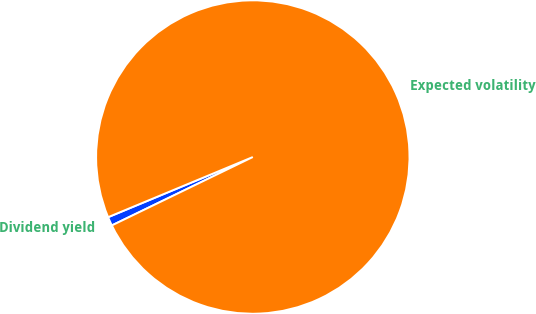Convert chart to OTSL. <chart><loc_0><loc_0><loc_500><loc_500><pie_chart><fcel>Dividend yield<fcel>Expected volatility<nl><fcel>0.92%<fcel>99.08%<nl></chart> 